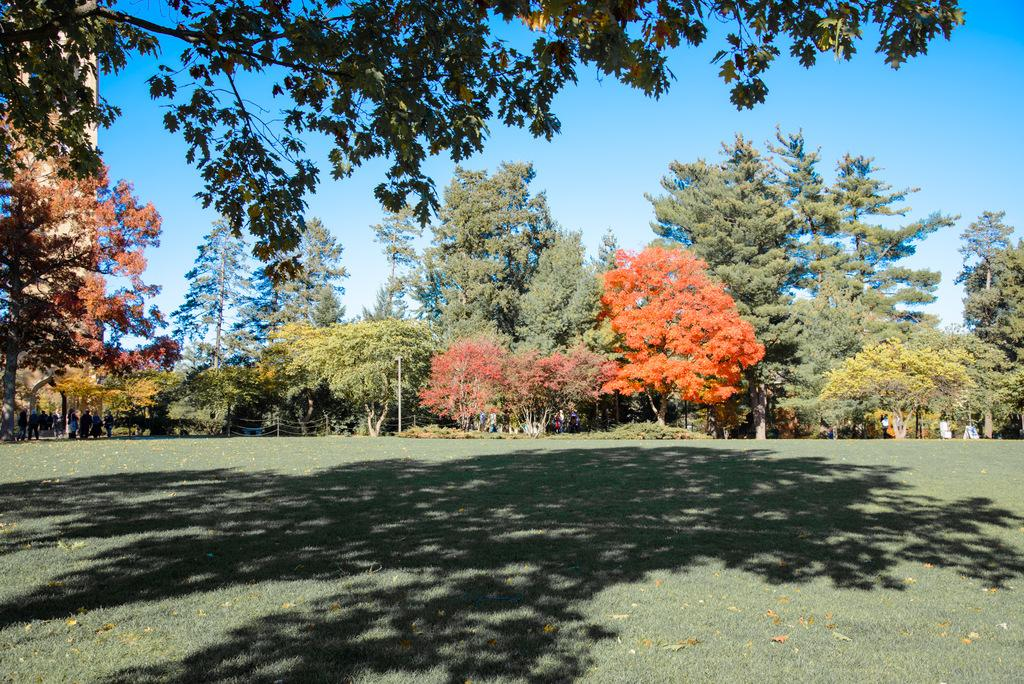What type of vegetation is predominant in the image? There are many trees in the image. Can you identify a specific type of tree in the image? Yes, there is an orange tree in the front. What is the color of the grass at the bottom of the image? The grass at the bottom of the image is green. What can be seen at the top of the image? The sky is visible at the top of the image. Where is the father standing with the goose in the image? There is no father or goose present in the image. How many trains can be seen passing by in the image? There are no trains visible in the image. 